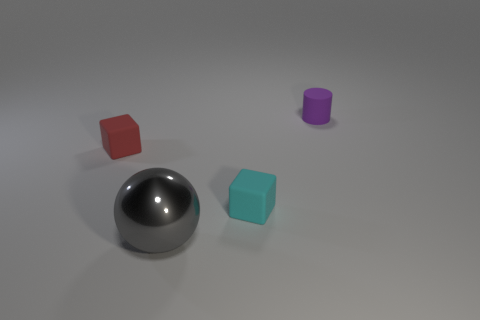Is there anything else that is made of the same material as the gray ball?
Provide a short and direct response. No. Are there any cyan rubber blocks that are to the left of the metal object in front of the tiny matte cube that is right of the big sphere?
Keep it short and to the point. No. There is a object in front of the cyan rubber cube; what material is it?
Offer a terse response. Metal. What number of tiny objects are either brown metallic cubes or cyan rubber things?
Your answer should be very brief. 1. There is a object on the left side of the gray shiny sphere; does it have the same size as the tiny purple object?
Offer a terse response. Yes. What is the red cube made of?
Give a very brief answer. Rubber. There is a tiny thing that is on the right side of the large ball and in front of the tiny purple thing; what material is it?
Provide a short and direct response. Rubber. What number of objects are either tiny matte objects on the left side of the matte cylinder or tiny blocks?
Your answer should be very brief. 2. Is there a cyan thing of the same size as the purple thing?
Your answer should be compact. Yes. How many objects are both in front of the tiny red thing and behind the gray ball?
Offer a very short reply. 1. 